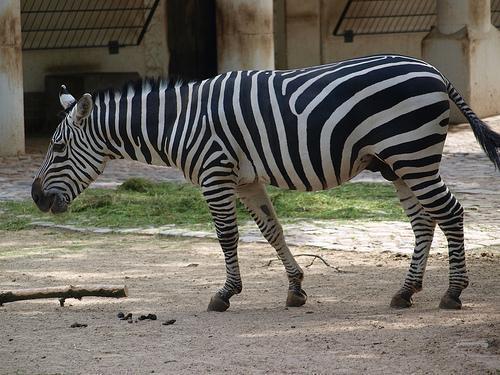How many legs does the zebra have?
Give a very brief answer. 4. How many zebras are playing football?
Give a very brief answer. 0. 